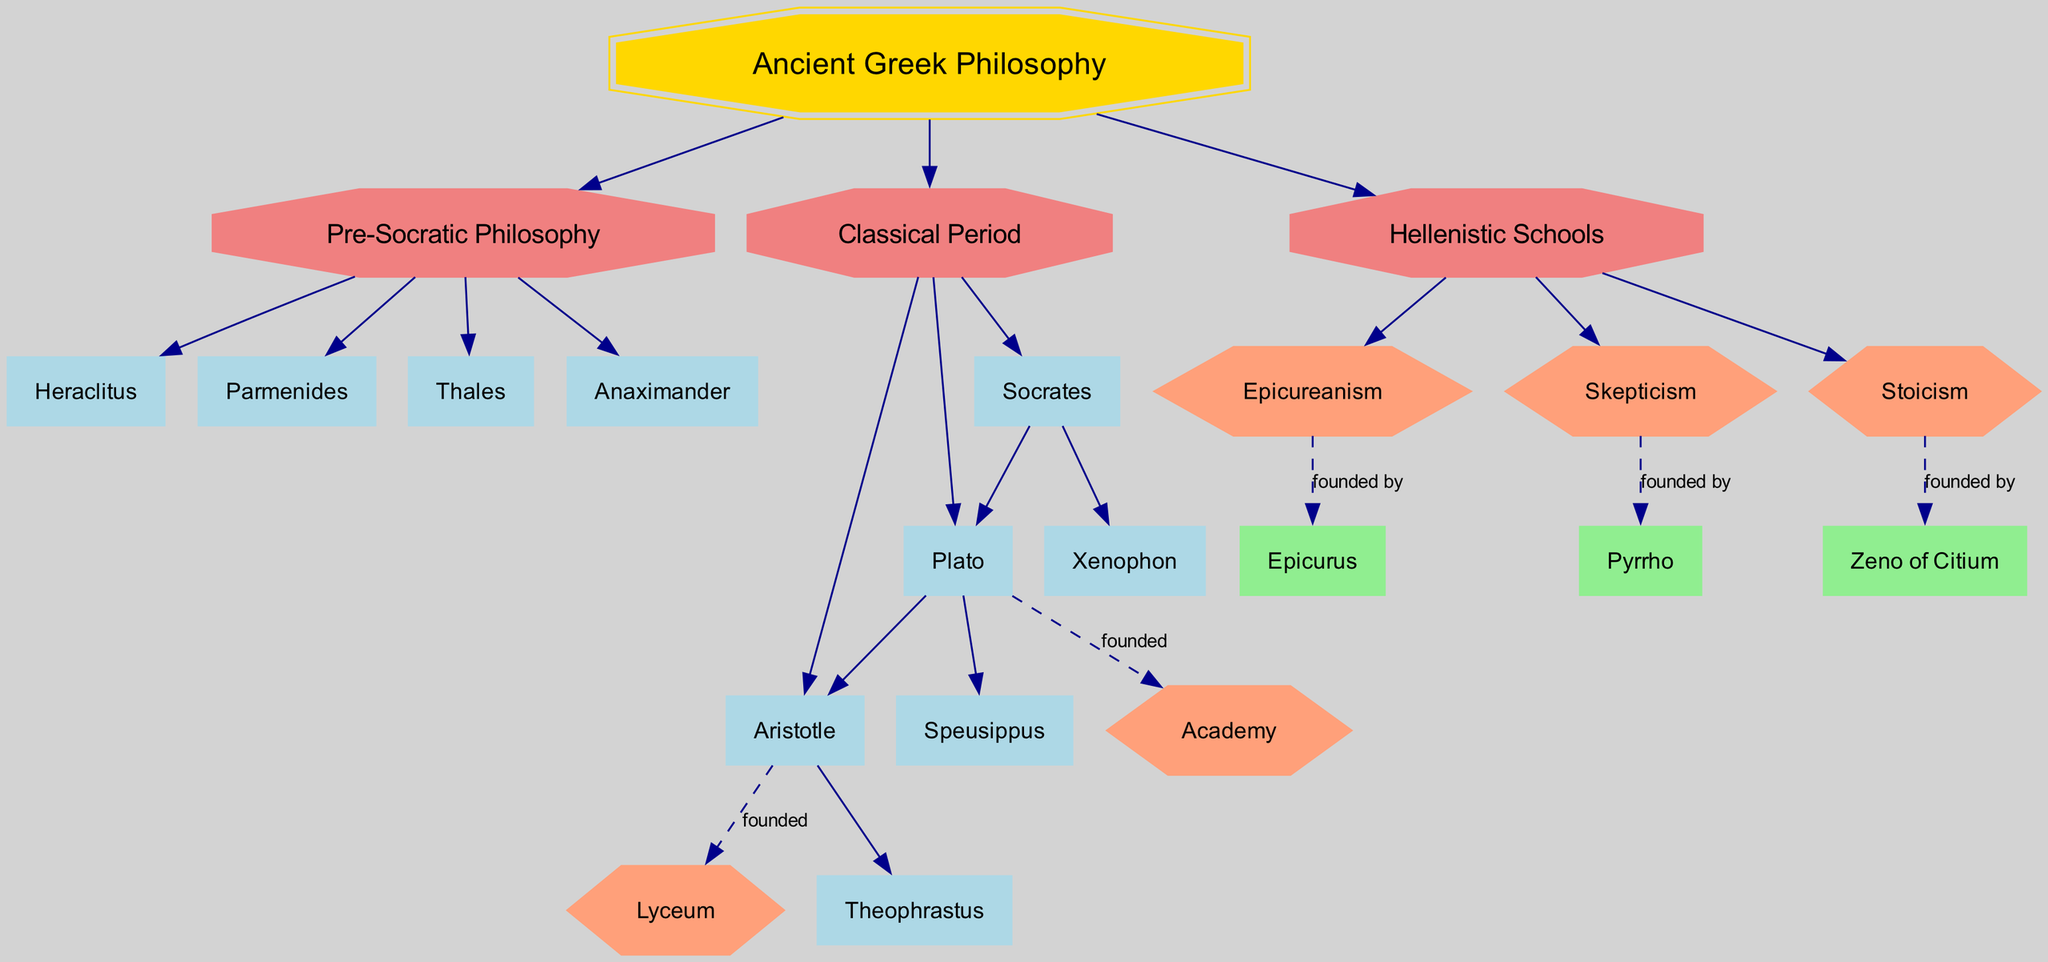What is the root of the family tree? The root of the family tree is the overarching category, which in this case is "Ancient Greek Philosophy." This can be identified as the main starting point from which all branches originate in the diagram.
Answer: Ancient Greek Philosophy How many philosophers are listed in Pre-Socratic Philosophy? In the Pre-Socratic Philosophy branch, the philosophers listed are Thales, Anaximander, Heraclitus, and Parmenides. Counting these names gives a total of four philosophers, which is confirmed by identifying them individually in that branch section of the diagram.
Answer: 4 Who founded the School of Stoicism? The School of Stoicism is connected to its founder, Zeno of Citium, shown in the Hellenistic Schools branch of the diagram. This can be confirmed by tracing the edges that connect the school node to the founder's node.
Answer: Zeno of Citium Which philosopher is a student of Socrates? Socrates has two students listed: Plato and Xenophon. By examining the Classical Period branch, we can identify these students directly under the node for Socrates. Therefore, either name is acceptable as a correct answer.
Answer: Plato or Xenophon Which school did Aristotle belong to? Aristotle is classified under the school called Lyceum in the diagram. The school node can be found directly connected to Aristotle, indicating his association with it.
Answer: Lyceum How many branches are there in Ancient Greek Philosophy? Inspecting the root, we can see there are three main branches: Pre-Socratic Philosophy, Classical Period, and Hellenistic Schools. Counting these branches will confirm the total number.
Answer: 3 Who was a student of Plato? Among Plato's students listed in the diagram, Aristotle is notably mentioned, showing a direct student-teacher relationship. By recognizing this from the Classical Period branch, we see this student connection.
Answer: Aristotle What is the school associated with the founder Epicurus? Epicurus founded the school named Epicureanism, which is indicated in the Hellenistic Schools section of the diagram. This connection clearly associates the philosopher with the specific school.
Answer: Epicureanism Which philosopher is known for founding Skepticism? Pyrrho is identified as the founder of the school of Skepticism in the diagram. This can be traced from the node for the Skepticism school directly back to its founder.
Answer: Pyrrho 